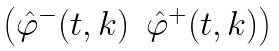Convert formula to latex. <formula><loc_0><loc_0><loc_500><loc_500>\begin{pmatrix} \hat { \varphi } ^ { - } ( t , k ) & \hat { \varphi } ^ { + } ( t , k ) \end{pmatrix}</formula> 